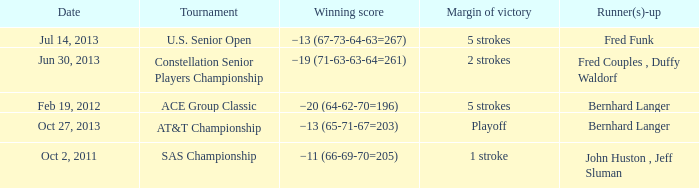Could you help me parse every detail presented in this table? {'header': ['Date', 'Tournament', 'Winning score', 'Margin of victory', 'Runner(s)-up'], 'rows': [['Jul 14, 2013', 'U.S. Senior Open', '−13 (67-73-64-63=267)', '5 strokes', 'Fred Funk'], ['Jun 30, 2013', 'Constellation Senior Players Championship', '−19 (71-63-63-64=261)', '2 strokes', 'Fred Couples , Duffy Waldorf'], ['Feb 19, 2012', 'ACE Group Classic', '−20 (64-62-70=196)', '5 strokes', 'Bernhard Langer'], ['Oct 27, 2013', 'AT&T Championship', '−13 (65-71-67=203)', 'Playoff', 'Bernhard Langer'], ['Oct 2, 2011', 'SAS Championship', '−11 (66-69-70=205)', '1 stroke', 'John Huston , Jeff Sluman']]} Which Date has a Runner(s)-up of fred funk? Jul 14, 2013. 